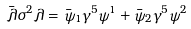Convert formula to latex. <formula><loc_0><loc_0><loc_500><loc_500>\bar { \lambda } \sigma ^ { 2 } \lambda = \bar { \psi } _ { 1 } \gamma ^ { 5 } \psi ^ { 1 } + \bar { \psi } _ { 2 } \gamma ^ { 5 } \psi ^ { 2 }</formula> 